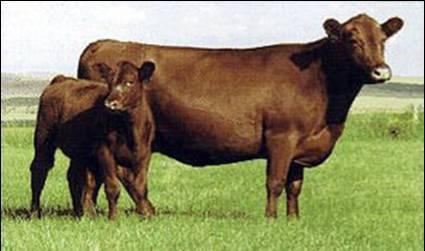How many cows are in this photo?
Give a very brief answer. 2. How many cows are there?
Give a very brief answer. 2. 